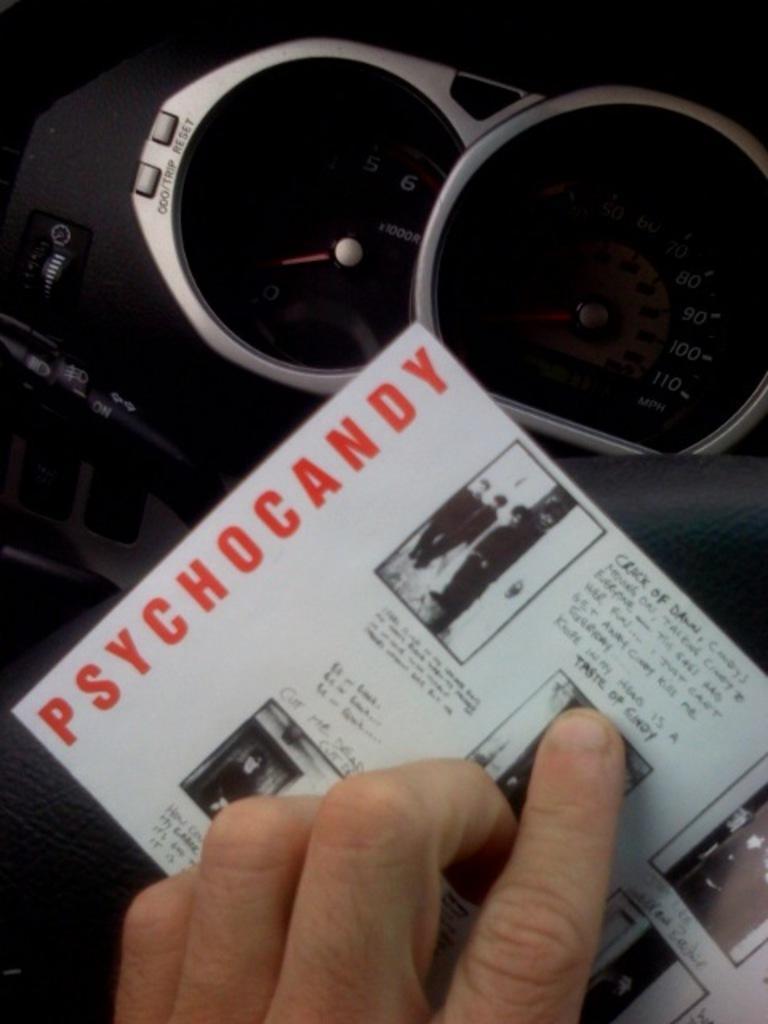Please provide a concise description of this image. In this picture I can see a person's fingers in front and I can see a paper on which there is something written. In the background I can see the speedometers and few buttons. 